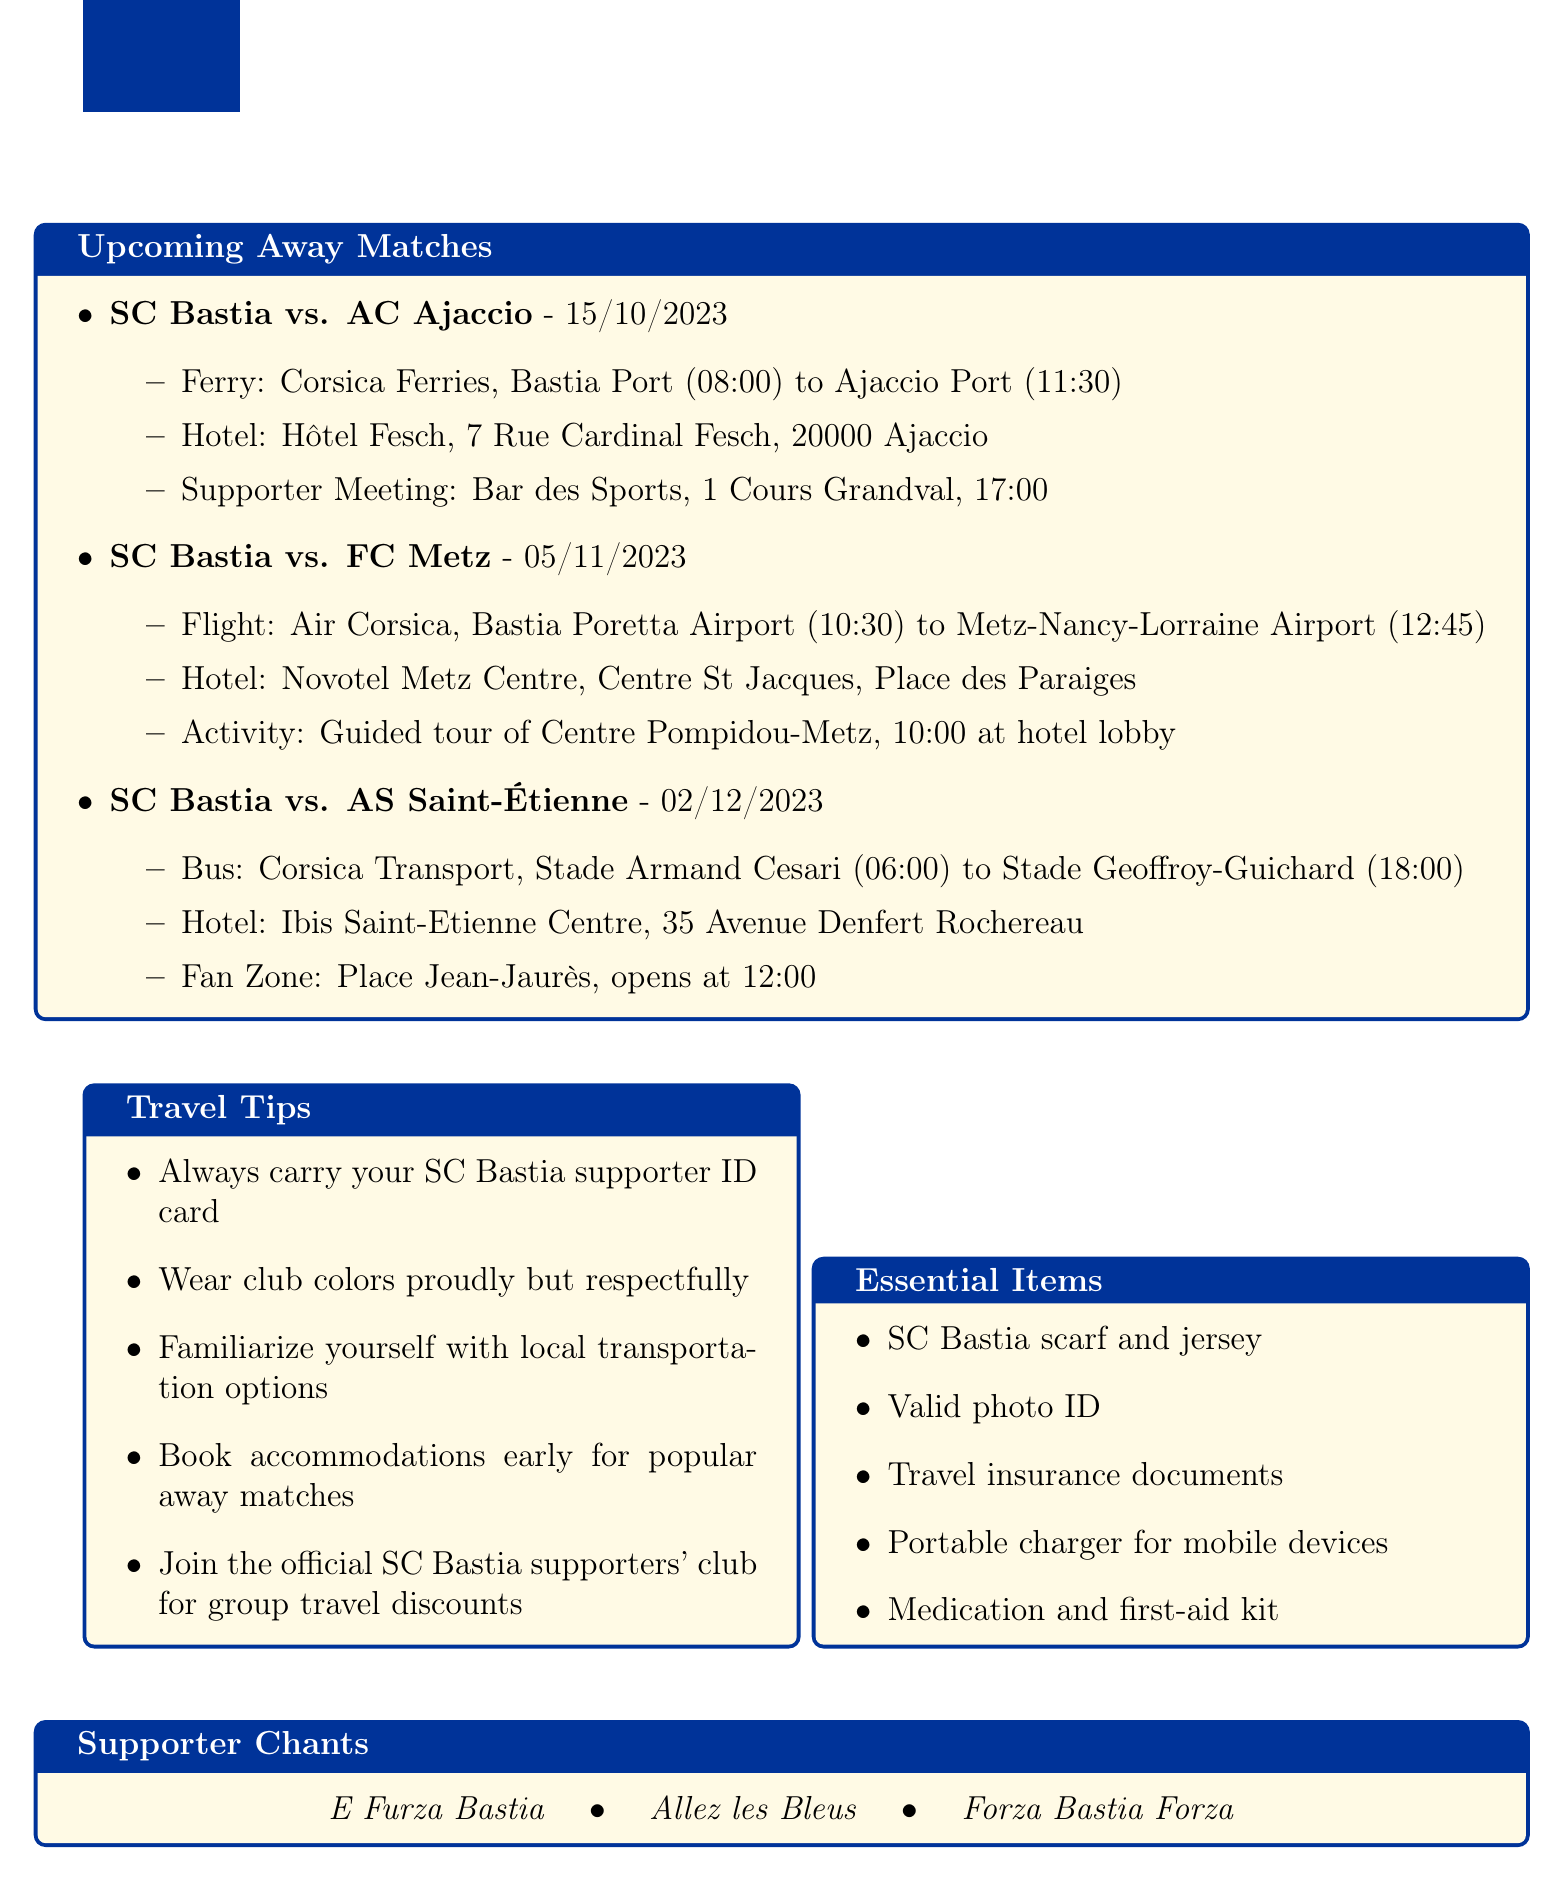What is the date of the match against AC Ajaccio? The date for the match against AC Ajaccio is explicitly mentioned in the document as October 15, 2023.
Answer: October 15, 2023 What mode of transportation is used for the match against FC Metz? The document specifies that the mode of transportation for the match against FC Metz is Flight.
Answer: Flight What hotel will the supporters stay at in Ajaccio? The document clearly states the hotel for supporters in Ajaccio is Hôtel Fesch.
Answer: Hôtel Fesch What time does the supporter group meeting take place for the match against AC Ajaccio? The document provides the time for the supporter group meeting, which is 17:00.
Answer: 17:00 How many stops are there on the way to AS Saint-Étienne? The document mentions two stops during the trip to AS Saint-Étienne.
Answer: Two What is the opening time for the fan zone at the AS Saint-Étienne match? The document specifies that the fan zone opens at 12:00.
Answer: 12:00 What is the duration of the layover for the flight to FC Metz? The document states that the layover duration for the flight to FC Metz is 1 hour and 30 minutes.
Answer: 1 hour 30 minutes Which company operates the ferry to Ajaccio? The document mentions that the ferry to Ajaccio is operated by Corsica Ferries.
Answer: Corsica Ferries What essential item is recommended to carry along during travels? The document lists several essential items, and one recommended item is a valid photo ID.
Answer: Valid photo ID 